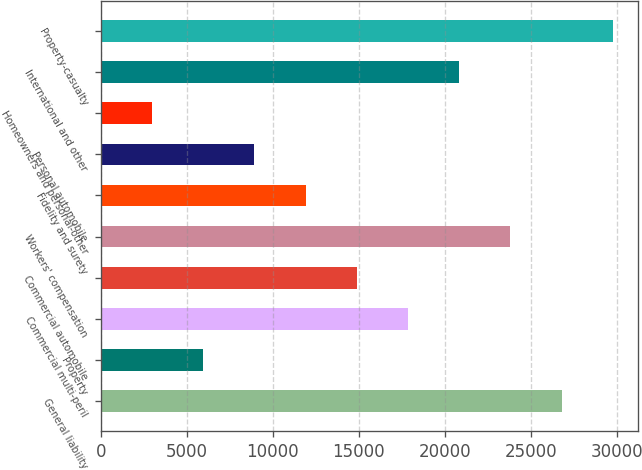<chart> <loc_0><loc_0><loc_500><loc_500><bar_chart><fcel>General liability<fcel>Property<fcel>Commercial multi-peril<fcel>Commercial automobile<fcel>Workers' compensation<fcel>Fidelity and surety<fcel>Personal automobile<fcel>Homeowners and personal-other<fcel>International and other<fcel>Property-casualty<nl><fcel>26779.6<fcel>5958.8<fcel>17856.4<fcel>14882<fcel>23805.2<fcel>11907.6<fcel>8933.2<fcel>2984.4<fcel>20830.8<fcel>29754<nl></chart> 